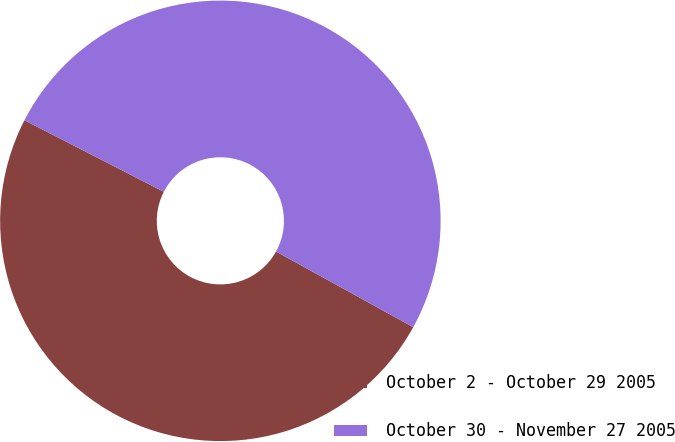Convert chart to OTSL. <chart><loc_0><loc_0><loc_500><loc_500><pie_chart><fcel>October 2 - October 29 2005<fcel>October 30 - November 27 2005<nl><fcel>49.53%<fcel>50.47%<nl></chart> 